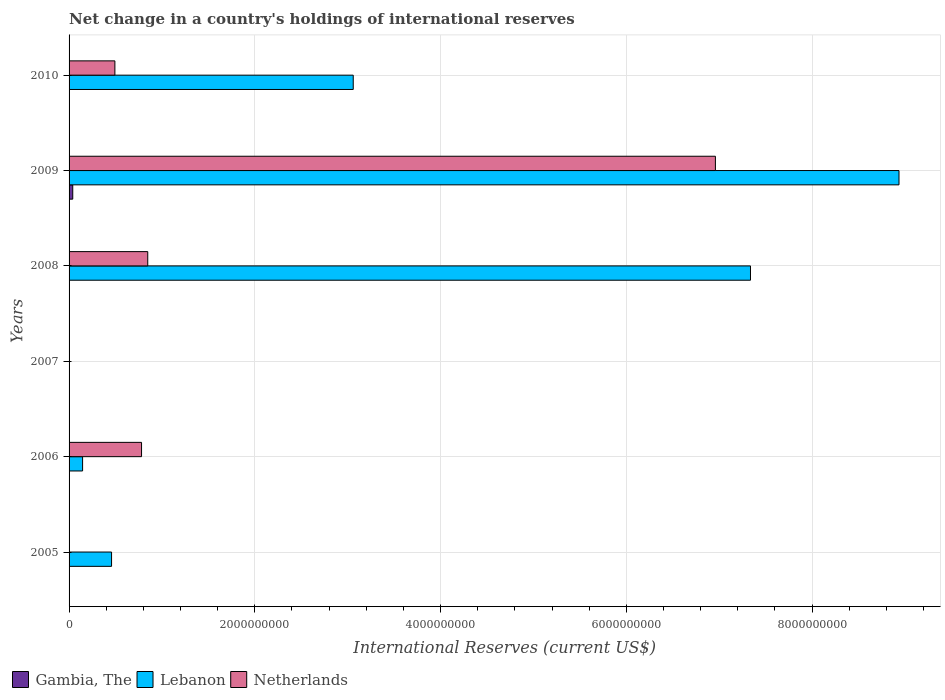How many different coloured bars are there?
Make the answer very short. 3. How many bars are there on the 3rd tick from the bottom?
Offer a terse response. 0. In how many cases, is the number of bars for a given year not equal to the number of legend labels?
Your answer should be very brief. 4. What is the international reserves in Gambia, The in 2008?
Provide a short and direct response. 0. Across all years, what is the maximum international reserves in Lebanon?
Ensure brevity in your answer.  8.94e+09. What is the total international reserves in Netherlands in the graph?
Give a very brief answer. 9.08e+09. What is the difference between the international reserves in Lebanon in 2006 and that in 2008?
Keep it short and to the point. -7.19e+09. What is the difference between the international reserves in Gambia, The in 2009 and the international reserves in Netherlands in 2008?
Ensure brevity in your answer.  -8.07e+08. What is the average international reserves in Netherlands per year?
Ensure brevity in your answer.  1.51e+09. In the year 2009, what is the difference between the international reserves in Gambia, The and international reserves in Lebanon?
Keep it short and to the point. -8.90e+09. In how many years, is the international reserves in Netherlands greater than 2800000000 US$?
Offer a very short reply. 1. What is the ratio of the international reserves in Lebanon in 2008 to that in 2010?
Give a very brief answer. 2.4. Is the international reserves in Netherlands in 2006 less than that in 2010?
Provide a succinct answer. No. Is the difference between the international reserves in Gambia, The in 2006 and 2009 greater than the difference between the international reserves in Lebanon in 2006 and 2009?
Give a very brief answer. Yes. What is the difference between the highest and the second highest international reserves in Netherlands?
Offer a very short reply. 6.11e+09. What is the difference between the highest and the lowest international reserves in Lebanon?
Offer a terse response. 8.94e+09. Is it the case that in every year, the sum of the international reserves in Lebanon and international reserves in Gambia, The is greater than the international reserves in Netherlands?
Offer a terse response. No. How many bars are there?
Ensure brevity in your answer.  11. How many years are there in the graph?
Offer a very short reply. 6. What is the difference between two consecutive major ticks on the X-axis?
Your response must be concise. 2.00e+09. How many legend labels are there?
Your answer should be compact. 3. How are the legend labels stacked?
Your answer should be compact. Horizontal. What is the title of the graph?
Your answer should be very brief. Net change in a country's holdings of international reserves. Does "Andorra" appear as one of the legend labels in the graph?
Your response must be concise. No. What is the label or title of the X-axis?
Provide a short and direct response. International Reserves (current US$). What is the International Reserves (current US$) in Gambia, The in 2005?
Provide a succinct answer. 0. What is the International Reserves (current US$) in Lebanon in 2005?
Provide a succinct answer. 4.58e+08. What is the International Reserves (current US$) in Netherlands in 2005?
Your answer should be compact. 0. What is the International Reserves (current US$) of Gambia, The in 2006?
Offer a terse response. 1.14e+06. What is the International Reserves (current US$) in Lebanon in 2006?
Make the answer very short. 1.46e+08. What is the International Reserves (current US$) of Netherlands in 2006?
Make the answer very short. 7.80e+08. What is the International Reserves (current US$) of Gambia, The in 2007?
Offer a terse response. 0. What is the International Reserves (current US$) in Lebanon in 2007?
Give a very brief answer. 0. What is the International Reserves (current US$) in Gambia, The in 2008?
Offer a terse response. 0. What is the International Reserves (current US$) of Lebanon in 2008?
Provide a succinct answer. 7.34e+09. What is the International Reserves (current US$) of Netherlands in 2008?
Ensure brevity in your answer.  8.47e+08. What is the International Reserves (current US$) of Gambia, The in 2009?
Make the answer very short. 3.96e+07. What is the International Reserves (current US$) in Lebanon in 2009?
Provide a succinct answer. 8.94e+09. What is the International Reserves (current US$) of Netherlands in 2009?
Your answer should be very brief. 6.96e+09. What is the International Reserves (current US$) of Gambia, The in 2010?
Offer a terse response. 0. What is the International Reserves (current US$) in Lebanon in 2010?
Offer a very short reply. 3.06e+09. What is the International Reserves (current US$) in Netherlands in 2010?
Your answer should be compact. 4.93e+08. Across all years, what is the maximum International Reserves (current US$) of Gambia, The?
Offer a terse response. 3.96e+07. Across all years, what is the maximum International Reserves (current US$) in Lebanon?
Your answer should be compact. 8.94e+09. Across all years, what is the maximum International Reserves (current US$) of Netherlands?
Offer a very short reply. 6.96e+09. Across all years, what is the minimum International Reserves (current US$) in Gambia, The?
Offer a terse response. 0. Across all years, what is the minimum International Reserves (current US$) in Lebanon?
Provide a succinct answer. 0. Across all years, what is the minimum International Reserves (current US$) of Netherlands?
Give a very brief answer. 0. What is the total International Reserves (current US$) in Gambia, The in the graph?
Your answer should be very brief. 4.07e+07. What is the total International Reserves (current US$) in Lebanon in the graph?
Offer a very short reply. 1.99e+1. What is the total International Reserves (current US$) in Netherlands in the graph?
Your answer should be very brief. 9.08e+09. What is the difference between the International Reserves (current US$) of Lebanon in 2005 and that in 2006?
Make the answer very short. 3.12e+08. What is the difference between the International Reserves (current US$) of Lebanon in 2005 and that in 2008?
Offer a terse response. -6.88e+09. What is the difference between the International Reserves (current US$) in Lebanon in 2005 and that in 2009?
Give a very brief answer. -8.48e+09. What is the difference between the International Reserves (current US$) in Lebanon in 2005 and that in 2010?
Your response must be concise. -2.60e+09. What is the difference between the International Reserves (current US$) in Lebanon in 2006 and that in 2008?
Provide a succinct answer. -7.19e+09. What is the difference between the International Reserves (current US$) in Netherlands in 2006 and that in 2008?
Ensure brevity in your answer.  -6.68e+07. What is the difference between the International Reserves (current US$) in Gambia, The in 2006 and that in 2009?
Offer a very short reply. -3.85e+07. What is the difference between the International Reserves (current US$) of Lebanon in 2006 and that in 2009?
Your answer should be compact. -8.79e+09. What is the difference between the International Reserves (current US$) in Netherlands in 2006 and that in 2009?
Ensure brevity in your answer.  -6.18e+09. What is the difference between the International Reserves (current US$) in Lebanon in 2006 and that in 2010?
Provide a succinct answer. -2.91e+09. What is the difference between the International Reserves (current US$) of Netherlands in 2006 and that in 2010?
Your answer should be very brief. 2.87e+08. What is the difference between the International Reserves (current US$) of Lebanon in 2008 and that in 2009?
Give a very brief answer. -1.60e+09. What is the difference between the International Reserves (current US$) of Netherlands in 2008 and that in 2009?
Offer a terse response. -6.11e+09. What is the difference between the International Reserves (current US$) in Lebanon in 2008 and that in 2010?
Give a very brief answer. 4.28e+09. What is the difference between the International Reserves (current US$) of Netherlands in 2008 and that in 2010?
Keep it short and to the point. 3.54e+08. What is the difference between the International Reserves (current US$) in Lebanon in 2009 and that in 2010?
Offer a very short reply. 5.88e+09. What is the difference between the International Reserves (current US$) of Netherlands in 2009 and that in 2010?
Your answer should be compact. 6.47e+09. What is the difference between the International Reserves (current US$) of Lebanon in 2005 and the International Reserves (current US$) of Netherlands in 2006?
Your answer should be compact. -3.23e+08. What is the difference between the International Reserves (current US$) of Lebanon in 2005 and the International Reserves (current US$) of Netherlands in 2008?
Offer a terse response. -3.90e+08. What is the difference between the International Reserves (current US$) in Lebanon in 2005 and the International Reserves (current US$) in Netherlands in 2009?
Your response must be concise. -6.50e+09. What is the difference between the International Reserves (current US$) of Lebanon in 2005 and the International Reserves (current US$) of Netherlands in 2010?
Keep it short and to the point. -3.59e+07. What is the difference between the International Reserves (current US$) in Gambia, The in 2006 and the International Reserves (current US$) in Lebanon in 2008?
Your answer should be compact. -7.34e+09. What is the difference between the International Reserves (current US$) in Gambia, The in 2006 and the International Reserves (current US$) in Netherlands in 2008?
Give a very brief answer. -8.46e+08. What is the difference between the International Reserves (current US$) of Lebanon in 2006 and the International Reserves (current US$) of Netherlands in 2008?
Your answer should be compact. -7.02e+08. What is the difference between the International Reserves (current US$) of Gambia, The in 2006 and the International Reserves (current US$) of Lebanon in 2009?
Offer a terse response. -8.93e+09. What is the difference between the International Reserves (current US$) of Gambia, The in 2006 and the International Reserves (current US$) of Netherlands in 2009?
Provide a succinct answer. -6.96e+09. What is the difference between the International Reserves (current US$) in Lebanon in 2006 and the International Reserves (current US$) in Netherlands in 2009?
Your answer should be very brief. -6.81e+09. What is the difference between the International Reserves (current US$) in Gambia, The in 2006 and the International Reserves (current US$) in Lebanon in 2010?
Provide a short and direct response. -3.06e+09. What is the difference between the International Reserves (current US$) in Gambia, The in 2006 and the International Reserves (current US$) in Netherlands in 2010?
Provide a short and direct response. -4.92e+08. What is the difference between the International Reserves (current US$) in Lebanon in 2006 and the International Reserves (current US$) in Netherlands in 2010?
Your answer should be very brief. -3.48e+08. What is the difference between the International Reserves (current US$) of Lebanon in 2008 and the International Reserves (current US$) of Netherlands in 2009?
Your answer should be compact. 3.78e+08. What is the difference between the International Reserves (current US$) of Lebanon in 2008 and the International Reserves (current US$) of Netherlands in 2010?
Provide a succinct answer. 6.84e+09. What is the difference between the International Reserves (current US$) in Gambia, The in 2009 and the International Reserves (current US$) in Lebanon in 2010?
Offer a terse response. -3.02e+09. What is the difference between the International Reserves (current US$) of Gambia, The in 2009 and the International Reserves (current US$) of Netherlands in 2010?
Offer a terse response. -4.54e+08. What is the difference between the International Reserves (current US$) in Lebanon in 2009 and the International Reserves (current US$) in Netherlands in 2010?
Your answer should be very brief. 8.44e+09. What is the average International Reserves (current US$) in Gambia, The per year?
Make the answer very short. 6.79e+06. What is the average International Reserves (current US$) of Lebanon per year?
Offer a terse response. 3.32e+09. What is the average International Reserves (current US$) of Netherlands per year?
Offer a terse response. 1.51e+09. In the year 2006, what is the difference between the International Reserves (current US$) of Gambia, The and International Reserves (current US$) of Lebanon?
Ensure brevity in your answer.  -1.44e+08. In the year 2006, what is the difference between the International Reserves (current US$) in Gambia, The and International Reserves (current US$) in Netherlands?
Provide a succinct answer. -7.79e+08. In the year 2006, what is the difference between the International Reserves (current US$) in Lebanon and International Reserves (current US$) in Netherlands?
Ensure brevity in your answer.  -6.35e+08. In the year 2008, what is the difference between the International Reserves (current US$) of Lebanon and International Reserves (current US$) of Netherlands?
Your response must be concise. 6.49e+09. In the year 2009, what is the difference between the International Reserves (current US$) of Gambia, The and International Reserves (current US$) of Lebanon?
Provide a succinct answer. -8.90e+09. In the year 2009, what is the difference between the International Reserves (current US$) in Gambia, The and International Reserves (current US$) in Netherlands?
Offer a very short reply. -6.92e+09. In the year 2009, what is the difference between the International Reserves (current US$) in Lebanon and International Reserves (current US$) in Netherlands?
Your answer should be very brief. 1.98e+09. In the year 2010, what is the difference between the International Reserves (current US$) in Lebanon and International Reserves (current US$) in Netherlands?
Make the answer very short. 2.57e+09. What is the ratio of the International Reserves (current US$) in Lebanon in 2005 to that in 2006?
Give a very brief answer. 3.14. What is the ratio of the International Reserves (current US$) in Lebanon in 2005 to that in 2008?
Give a very brief answer. 0.06. What is the ratio of the International Reserves (current US$) of Lebanon in 2005 to that in 2009?
Offer a terse response. 0.05. What is the ratio of the International Reserves (current US$) in Lebanon in 2005 to that in 2010?
Ensure brevity in your answer.  0.15. What is the ratio of the International Reserves (current US$) in Lebanon in 2006 to that in 2008?
Offer a very short reply. 0.02. What is the ratio of the International Reserves (current US$) in Netherlands in 2006 to that in 2008?
Provide a short and direct response. 0.92. What is the ratio of the International Reserves (current US$) of Gambia, The in 2006 to that in 2009?
Ensure brevity in your answer.  0.03. What is the ratio of the International Reserves (current US$) of Lebanon in 2006 to that in 2009?
Provide a short and direct response. 0.02. What is the ratio of the International Reserves (current US$) of Netherlands in 2006 to that in 2009?
Provide a short and direct response. 0.11. What is the ratio of the International Reserves (current US$) in Lebanon in 2006 to that in 2010?
Provide a succinct answer. 0.05. What is the ratio of the International Reserves (current US$) of Netherlands in 2006 to that in 2010?
Give a very brief answer. 1.58. What is the ratio of the International Reserves (current US$) in Lebanon in 2008 to that in 2009?
Give a very brief answer. 0.82. What is the ratio of the International Reserves (current US$) of Netherlands in 2008 to that in 2009?
Keep it short and to the point. 0.12. What is the ratio of the International Reserves (current US$) of Lebanon in 2008 to that in 2010?
Offer a very short reply. 2.4. What is the ratio of the International Reserves (current US$) of Netherlands in 2008 to that in 2010?
Keep it short and to the point. 1.72. What is the ratio of the International Reserves (current US$) of Lebanon in 2009 to that in 2010?
Your answer should be very brief. 2.92. What is the ratio of the International Reserves (current US$) in Netherlands in 2009 to that in 2010?
Keep it short and to the point. 14.1. What is the difference between the highest and the second highest International Reserves (current US$) in Lebanon?
Make the answer very short. 1.60e+09. What is the difference between the highest and the second highest International Reserves (current US$) of Netherlands?
Your answer should be very brief. 6.11e+09. What is the difference between the highest and the lowest International Reserves (current US$) of Gambia, The?
Your response must be concise. 3.96e+07. What is the difference between the highest and the lowest International Reserves (current US$) of Lebanon?
Give a very brief answer. 8.94e+09. What is the difference between the highest and the lowest International Reserves (current US$) of Netherlands?
Offer a very short reply. 6.96e+09. 